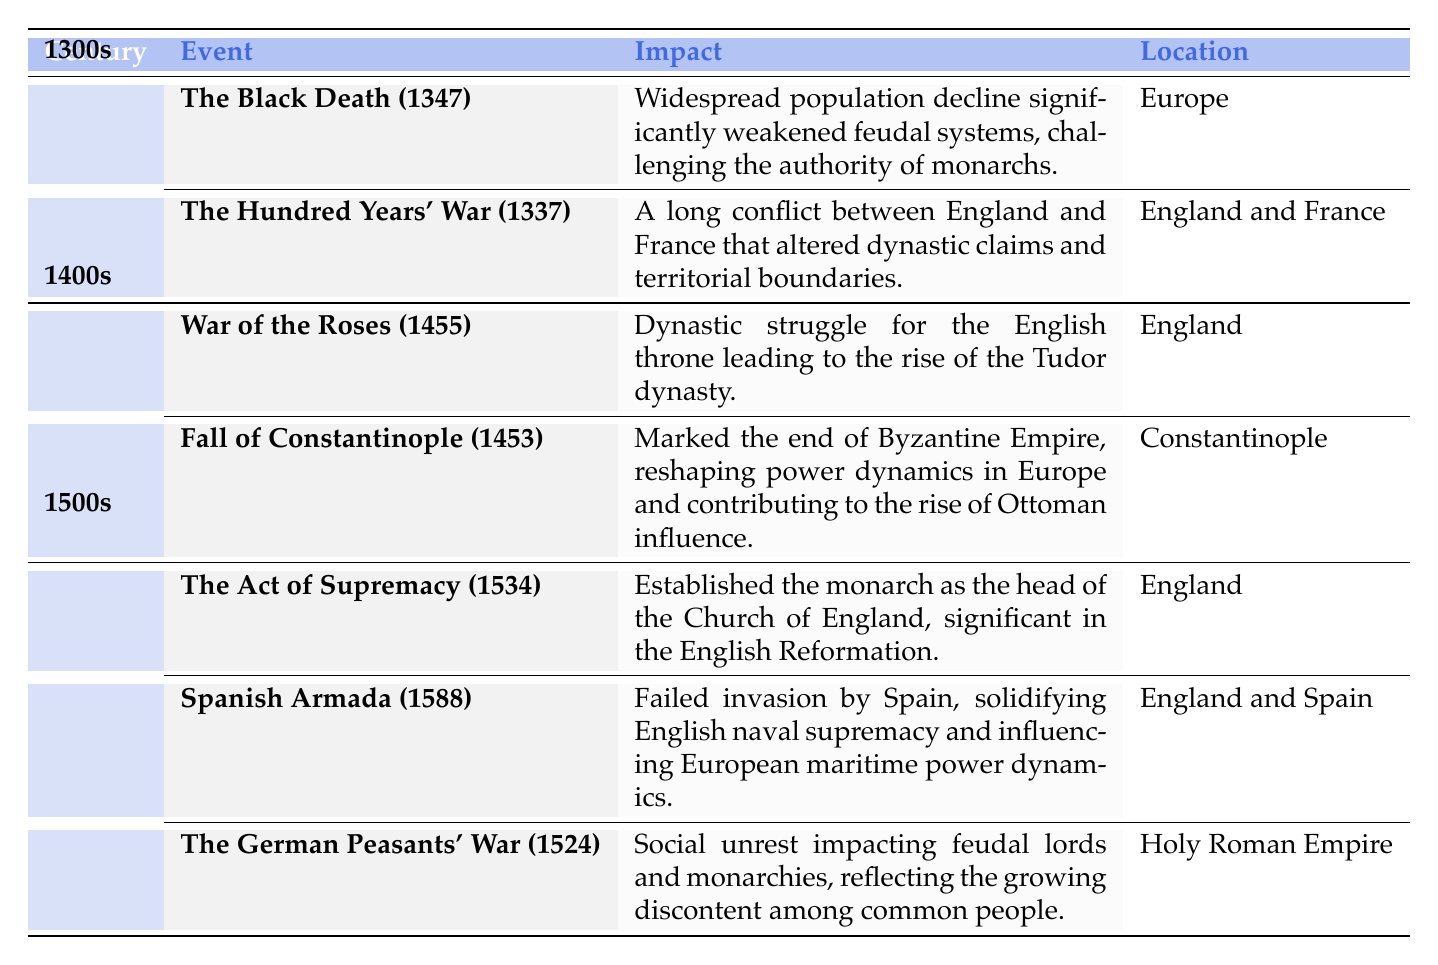What major event began in 1337? Referring to the table, the event listed under the 1300s that began in 1337 is "The Hundred Years' War."
Answer: The Hundred Years' War How did the Black Death impact monarchy? The table states that the Black Death weakened feudal systems and challenged the authority of monarchs, indicating a significant impact on royalty and governance.
Answer: It weakened feudal systems What year did the Fall of Constantinople occur? By checking the decade of the 1400s in the table, the Fall of Constantinople is noted to have occurred in 1453.
Answer: 1453 Was the Act of Supremacy significant for the Church of England? The table clearly indicates that the Act of Supremacy established the monarch as the head of the Church of England, highlighting its significance in the English Reformation.
Answer: Yes What was the number of major events listed for the 1500s? The table presents three events under the 1500s: The Act of Supremacy, Spanish Armada, and The German Peasants' War, summing them gives a total of 3 major events.
Answer: 3 If a conflict started affecting both England and France in 1337 and continued for 116 years, in what year did it end? The conflict started in 1337 and lasted for 116 years, so we add 116 to 1337 to get 1453, which matches the year given for the end of the Hundred Years' War in the table.
Answer: 1453 What is the average time difference between the events in the 1400s? The events in the 1400s occurred in 1455 and 1453. Since both events happened within the same decade, the difference is negligible, leading to an average of 1 year.
Answer: 1 year Which event contributed to the rise of Ottoman influence? The Fall of Constantinople in 1453 is specifically noted in the table as an event that reshaped power dynamics in Europe, contributing to the rise of Ottoman influence.
Answer: Fall of Constantinople What was the impact of the Spanish Armada in 1588 on England? The table states that the Spanish Armada was a failed invasion by Spain, which solidified English naval supremacy, thereby affirming England's position in European maritime power dynamics.
Answer: Solidified English naval supremacy 